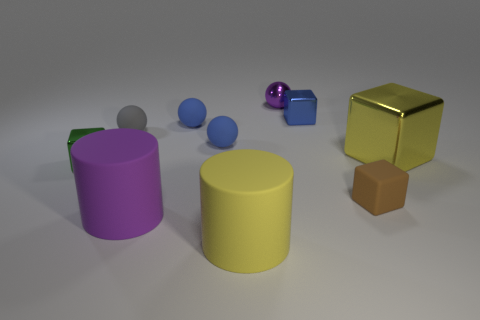There is a purple thing in front of the small cube that is behind the small block that is to the left of the yellow matte thing; what shape is it?
Make the answer very short. Cylinder. There is a small thing that is both in front of the tiny blue metallic cube and on the right side of the shiny sphere; what is its shape?
Make the answer very short. Cube. Is there a green thing that has the same material as the small gray object?
Provide a short and direct response. No. What size is the rubber cylinder that is the same color as the big metallic cube?
Ensure brevity in your answer.  Large. There is a small metallic block behind the green metal cube; what is its color?
Your response must be concise. Blue. There is a brown object; does it have the same shape as the large thing that is on the left side of the yellow matte cylinder?
Your answer should be compact. No. Is there another sphere that has the same color as the shiny ball?
Keep it short and to the point. No. There is a yellow object that is made of the same material as the small purple sphere; what size is it?
Keep it short and to the point. Large. Is the tiny metal ball the same color as the big block?
Keep it short and to the point. No. There is a tiny blue matte object that is in front of the gray matte sphere; is its shape the same as the tiny green thing?
Your answer should be very brief. No. 